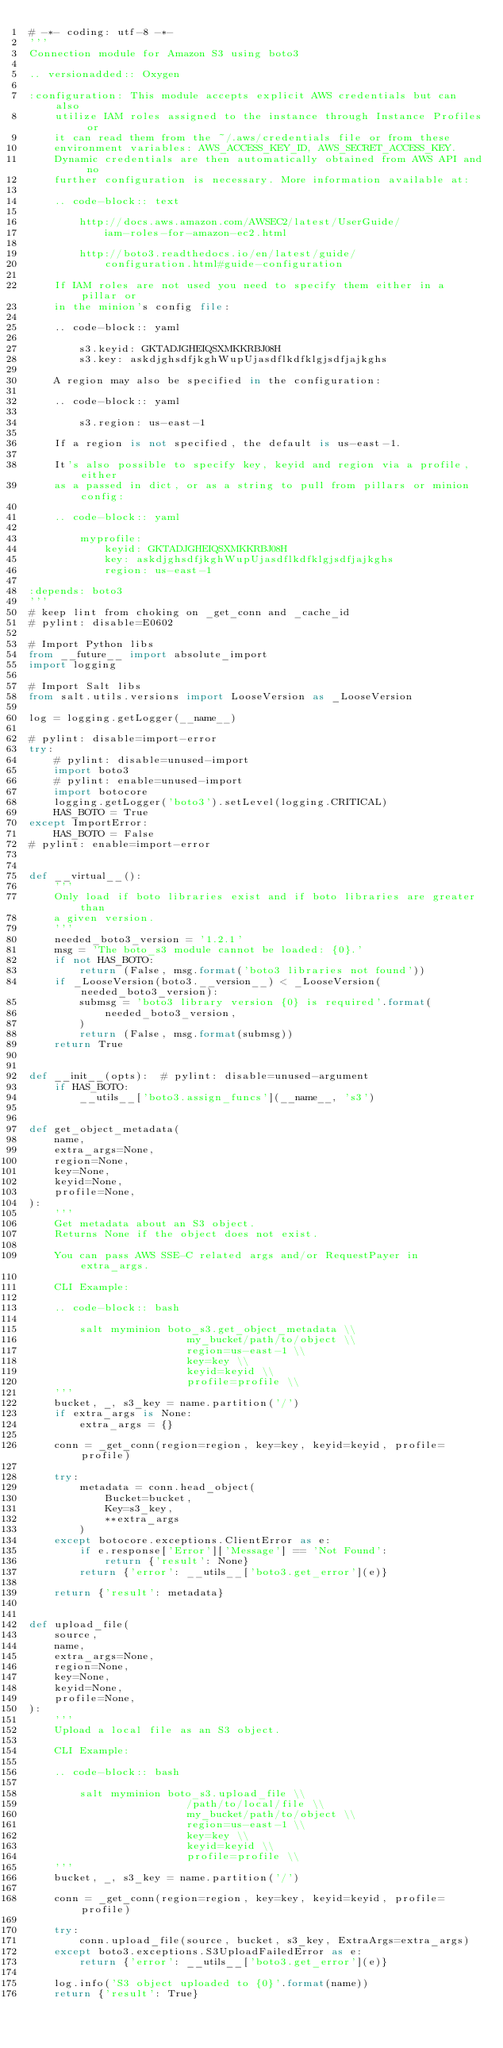Convert code to text. <code><loc_0><loc_0><loc_500><loc_500><_Python_># -*- coding: utf-8 -*-
'''
Connection module for Amazon S3 using boto3

.. versionadded:: Oxygen

:configuration: This module accepts explicit AWS credentials but can also
    utilize IAM roles assigned to the instance through Instance Profiles or
    it can read them from the ~/.aws/credentials file or from these
    environment variables: AWS_ACCESS_KEY_ID, AWS_SECRET_ACCESS_KEY.
    Dynamic credentials are then automatically obtained from AWS API and no
    further configuration is necessary. More information available at:

    .. code-block:: text

        http://docs.aws.amazon.com/AWSEC2/latest/UserGuide/
            iam-roles-for-amazon-ec2.html

        http://boto3.readthedocs.io/en/latest/guide/
            configuration.html#guide-configuration

    If IAM roles are not used you need to specify them either in a pillar or
    in the minion's config file:

    .. code-block:: yaml

        s3.keyid: GKTADJGHEIQSXMKKRBJ08H
        s3.key: askdjghsdfjkghWupUjasdflkdfklgjsdfjajkghs

    A region may also be specified in the configuration:

    .. code-block:: yaml

        s3.region: us-east-1

    If a region is not specified, the default is us-east-1.

    It's also possible to specify key, keyid and region via a profile, either
    as a passed in dict, or as a string to pull from pillars or minion config:

    .. code-block:: yaml

        myprofile:
            keyid: GKTADJGHEIQSXMKKRBJ08H
            key: askdjghsdfjkghWupUjasdflkdfklgjsdfjajkghs
            region: us-east-1

:depends: boto3
'''
# keep lint from choking on _get_conn and _cache_id
# pylint: disable=E0602

# Import Python libs
from __future__ import absolute_import
import logging

# Import Salt libs
from salt.utils.versions import LooseVersion as _LooseVersion

log = logging.getLogger(__name__)

# pylint: disable=import-error
try:
    # pylint: disable=unused-import
    import boto3
    # pylint: enable=unused-import
    import botocore
    logging.getLogger('boto3').setLevel(logging.CRITICAL)
    HAS_BOTO = True
except ImportError:
    HAS_BOTO = False
# pylint: enable=import-error


def __virtual__():
    '''
    Only load if boto libraries exist and if boto libraries are greater than
    a given version.
    '''
    needed_boto3_version = '1.2.1'
    msg = 'The boto_s3 module cannot be loaded: {0}.'
    if not HAS_BOTO:
        return (False, msg.format('boto3 libraries not found'))
    if _LooseVersion(boto3.__version__) < _LooseVersion(needed_boto3_version):
        submsg = 'boto3 library version {0} is required'.format(
            needed_boto3_version,
        )
        return (False, msg.format(submsg))
    return True


def __init__(opts):  # pylint: disable=unused-argument
    if HAS_BOTO:
        __utils__['boto3.assign_funcs'](__name__, 's3')


def get_object_metadata(
    name,
    extra_args=None,
    region=None,
    key=None,
    keyid=None,
    profile=None,
):
    '''
    Get metadata about an S3 object.
    Returns None if the object does not exist.

    You can pass AWS SSE-C related args and/or RequestPayer in extra_args.

    CLI Example:

    .. code-block:: bash

        salt myminion boto_s3.get_object_metadata \\
                         my_bucket/path/to/object \\
                         region=us-east-1 \\
                         key=key \\
                         keyid=keyid \\
                         profile=profile \\
    '''
    bucket, _, s3_key = name.partition('/')
    if extra_args is None:
        extra_args = {}

    conn = _get_conn(region=region, key=key, keyid=keyid, profile=profile)

    try:
        metadata = conn.head_object(
            Bucket=bucket,
            Key=s3_key,
            **extra_args
        )
    except botocore.exceptions.ClientError as e:
        if e.response['Error']['Message'] == 'Not Found':
            return {'result': None}
        return {'error': __utils__['boto3.get_error'](e)}

    return {'result': metadata}


def upload_file(
    source,
    name,
    extra_args=None,
    region=None,
    key=None,
    keyid=None,
    profile=None,
):
    '''
    Upload a local file as an S3 object.

    CLI Example:

    .. code-block:: bash

        salt myminion boto_s3.upload_file \\
                         /path/to/local/file \\
                         my_bucket/path/to/object \\
                         region=us-east-1 \\
                         key=key \\
                         keyid=keyid \\
                         profile=profile \\
    '''
    bucket, _, s3_key = name.partition('/')

    conn = _get_conn(region=region, key=key, keyid=keyid, profile=profile)

    try:
        conn.upload_file(source, bucket, s3_key, ExtraArgs=extra_args)
    except boto3.exceptions.S3UploadFailedError as e:
        return {'error': __utils__['boto3.get_error'](e)}

    log.info('S3 object uploaded to {0}'.format(name))
    return {'result': True}
</code> 